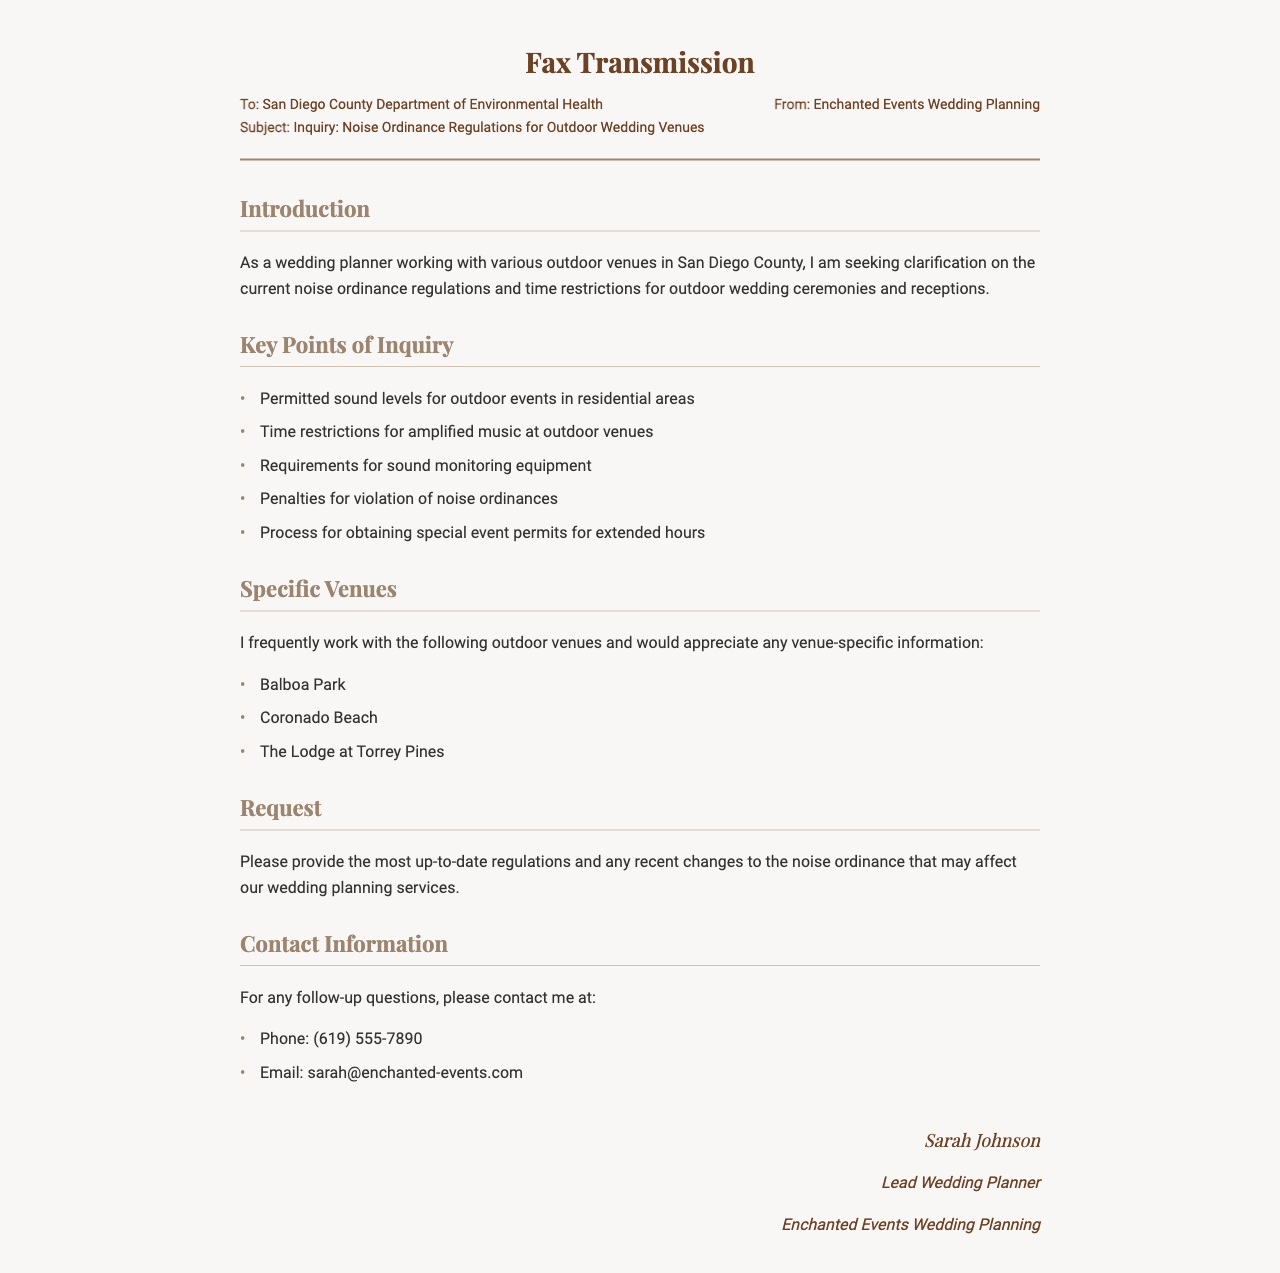What is the name of the sender? The sender is identified in the document as "Enchanted Events Wedding Planning."
Answer: Enchanted Events Wedding Planning What is the subject of the fax? The subject line indicates the focus of the inquiry, which is about noise ordinance regulations for outdoor wedding venues.
Answer: Inquiry: Noise Ordinance Regulations for Outdoor Wedding Venues Who is the lead wedding planner? The document specifies the name of the lead wedding planner as "Sarah Johnson."
Answer: Sarah Johnson What are the hours for amplified music at outdoor venues? The document mentions "time restrictions for amplified music" as a key point of inquiry but does not provide specific hours.
Answer: Not provided How many outdoor venues are mentioned? The document lists three specific outdoor venues the sender frequently works with.
Answer: Three What is a requirement mentioned for outdoor events? The document mentions needing "sound monitoring equipment" as one of the requirements for outdoor events.
Answer: Sound monitoring equipment What is the contact phone number provided? The document includes a contact phone number for follow-up questions.
Answer: (619) 555-7890 What venue is listed first in the specific venues section? The first venue mentioned in the list is "Balboa Park."
Answer: Balboa Park What is the request made in the document? The sender requests up-to-date regulations and information on any recent changes to the noise ordinance.
Answer: Up-to-date regulations and recent changes to the noise ordinance 